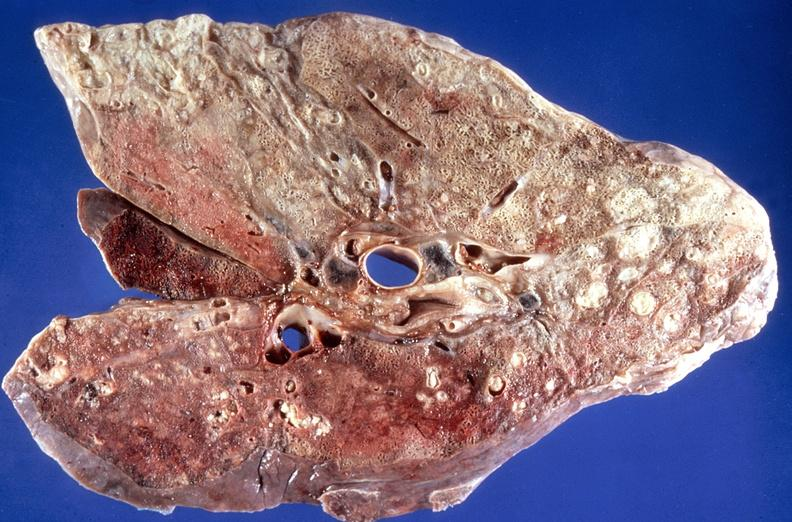s linear fracture in occiput present?
Answer the question using a single word or phrase. No 